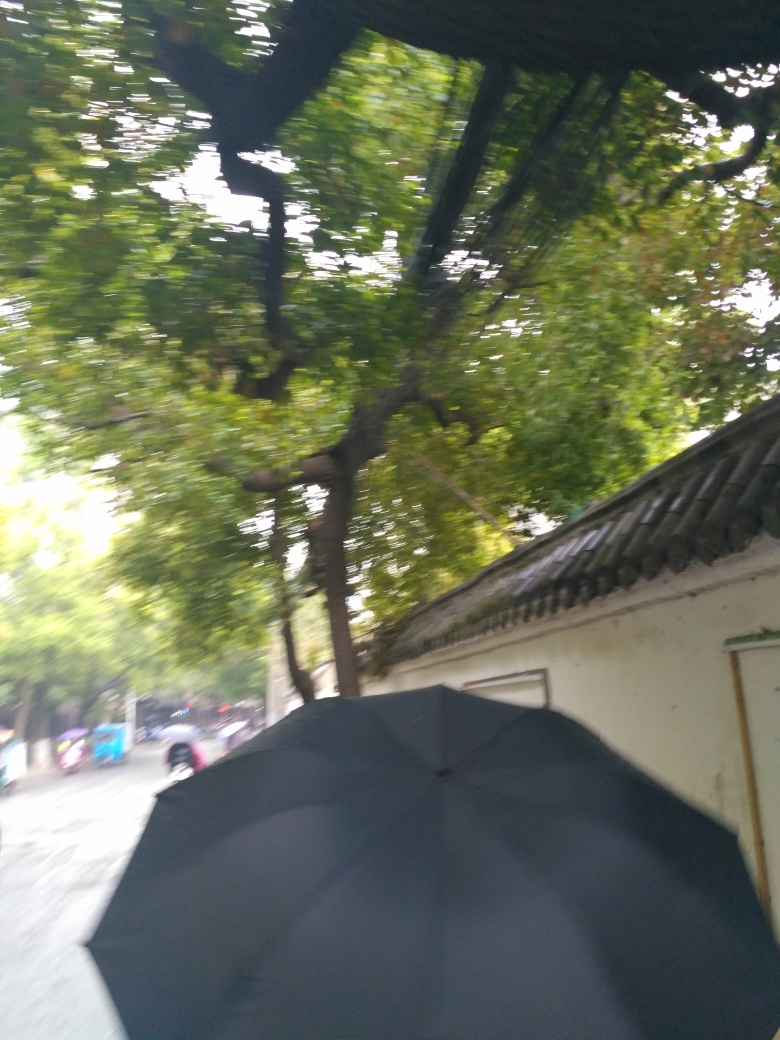What time of day does this image appear to have been taken? The lighting in the image is soft and diffuse, lacking strong shadows, which often indicates the photo was taken on an overcast day or possibly during the early morning or late afternoon hours. 